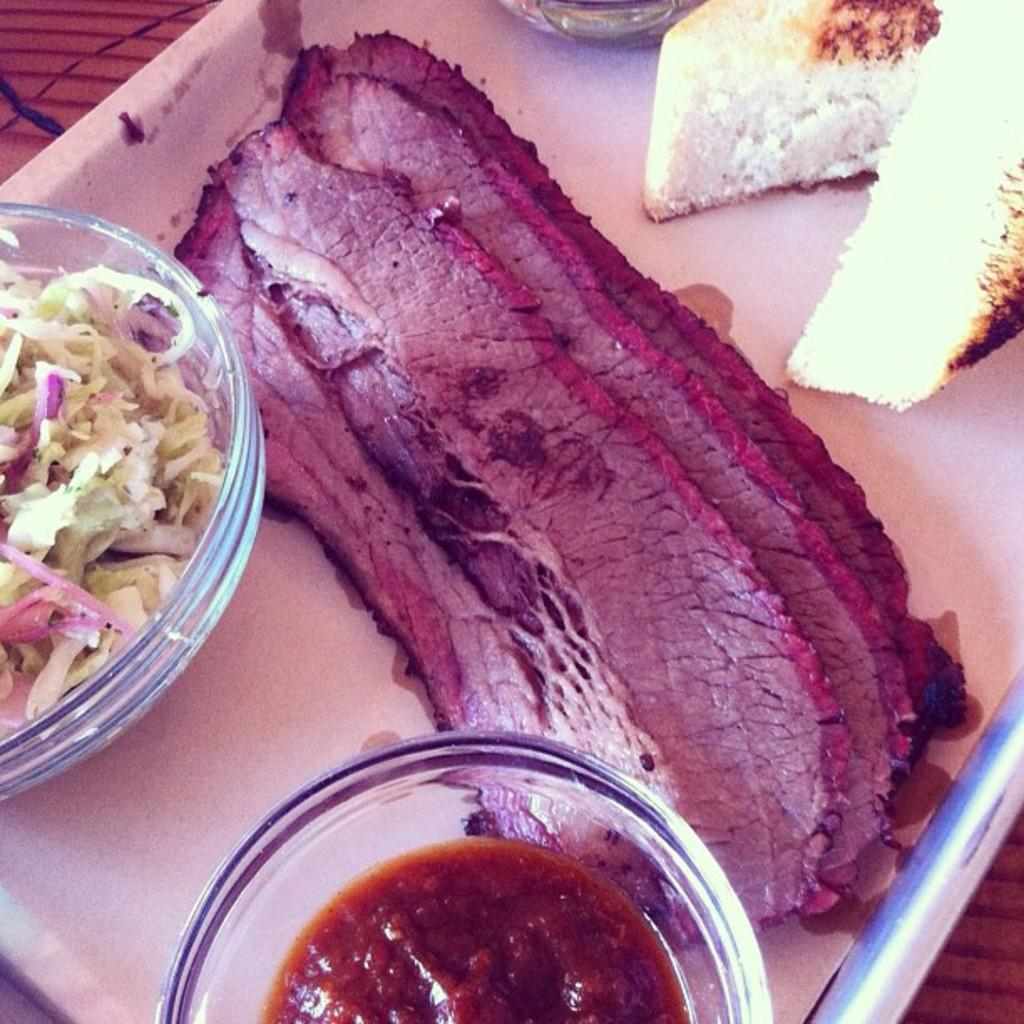What is the main object in the foreground of the image? There is a platter in the foreground of the image. What type of food is on the platter? The platter contains meat, a bowl of salad, a bowl of sauce, and two bread pieces. How many types of food are on the platter? There are four types of food on the platter: meat, salad, sauce, and bread. How does the goldfish contribute to the meal on the platter? There is no goldfish present on the platter or in the image. 